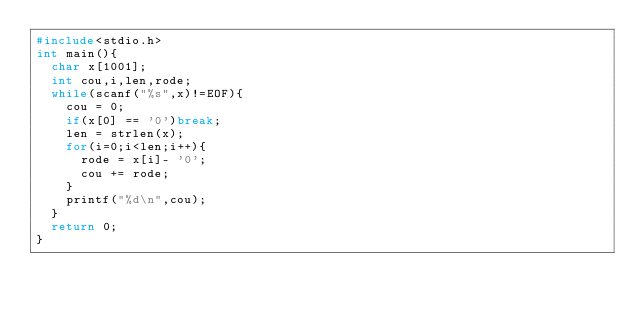Convert code to text. <code><loc_0><loc_0><loc_500><loc_500><_C_>#include<stdio.h>
int main(){
  char x[1001];
  int cou,i,len,rode;
  while(scanf("%s",x)!=EOF){
    cou = 0;
    if(x[0] == '0')break;
    len = strlen(x);
    for(i=0;i<len;i++){
      rode = x[i]- '0';
      cou += rode;
    }
    printf("%d\n",cou);
  }
  return 0;
}</code> 